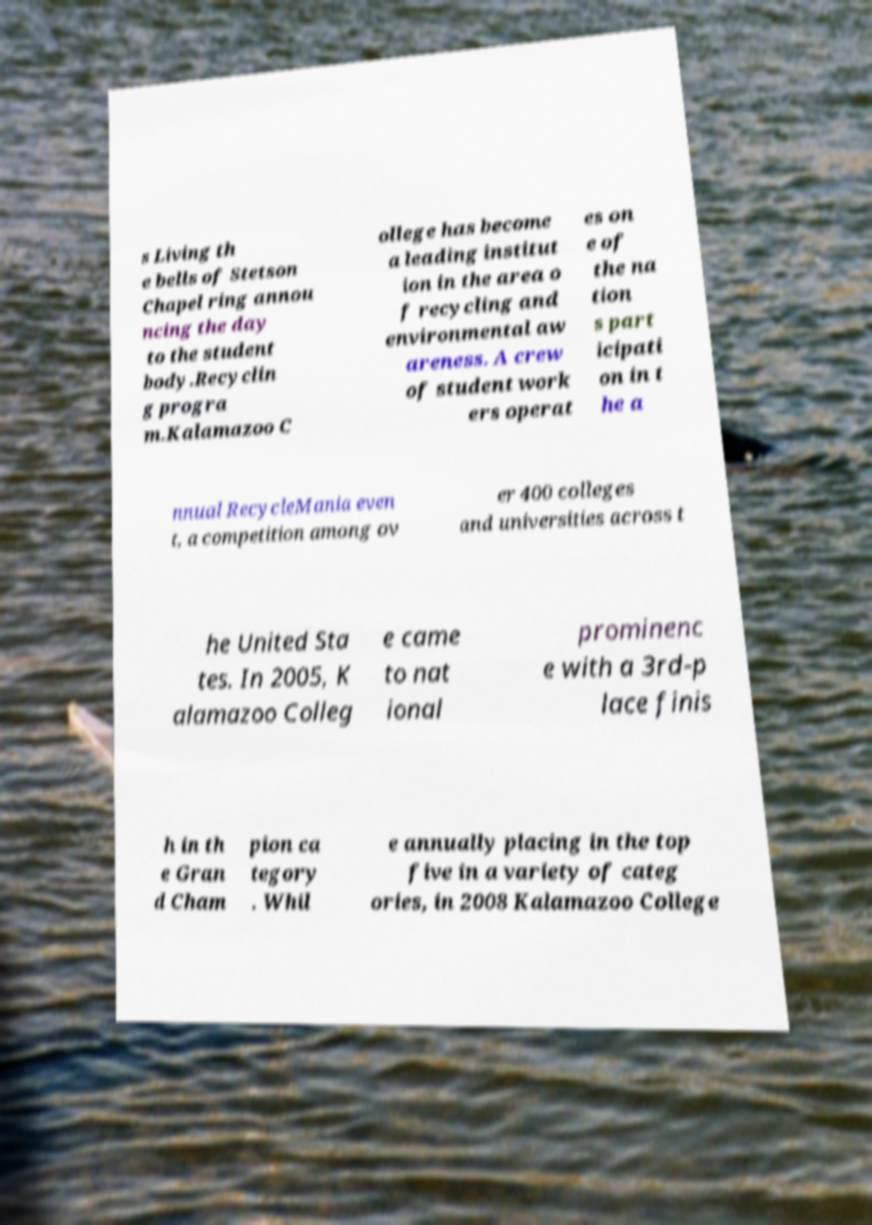Please identify and transcribe the text found in this image. s Living th e bells of Stetson Chapel ring annou ncing the day to the student body.Recyclin g progra m.Kalamazoo C ollege has become a leading institut ion in the area o f recycling and environmental aw areness. A crew of student work ers operat es on e of the na tion s part icipati on in t he a nnual RecycleMania even t, a competition among ov er 400 colleges and universities across t he United Sta tes. In 2005, K alamazoo Colleg e came to nat ional prominenc e with a 3rd-p lace finis h in th e Gran d Cham pion ca tegory . Whil e annually placing in the top five in a variety of categ ories, in 2008 Kalamazoo College 